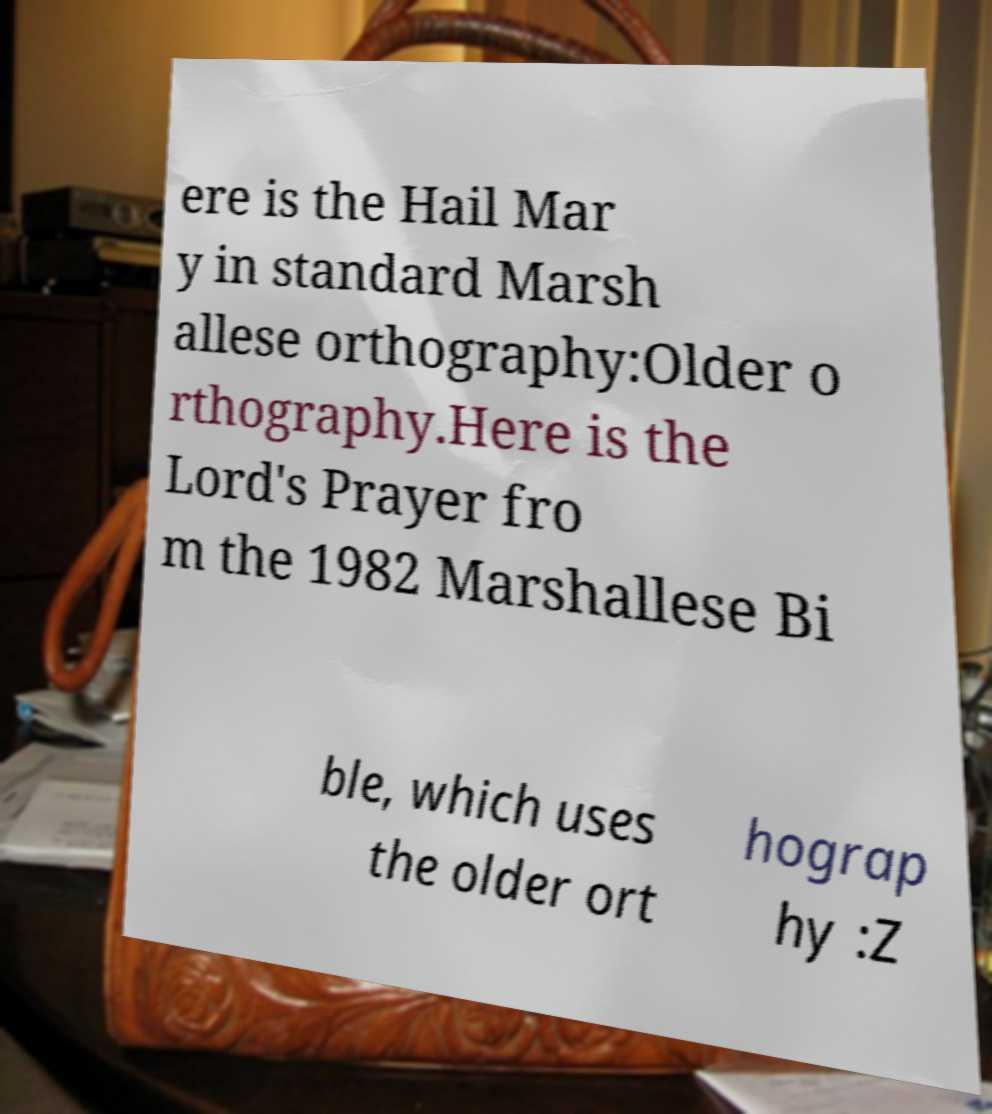Could you extract and type out the text from this image? ere is the Hail Mar y in standard Marsh allese orthography:Older o rthography.Here is the Lord's Prayer fro m the 1982 Marshallese Bi ble, which uses the older ort hograp hy :Z 